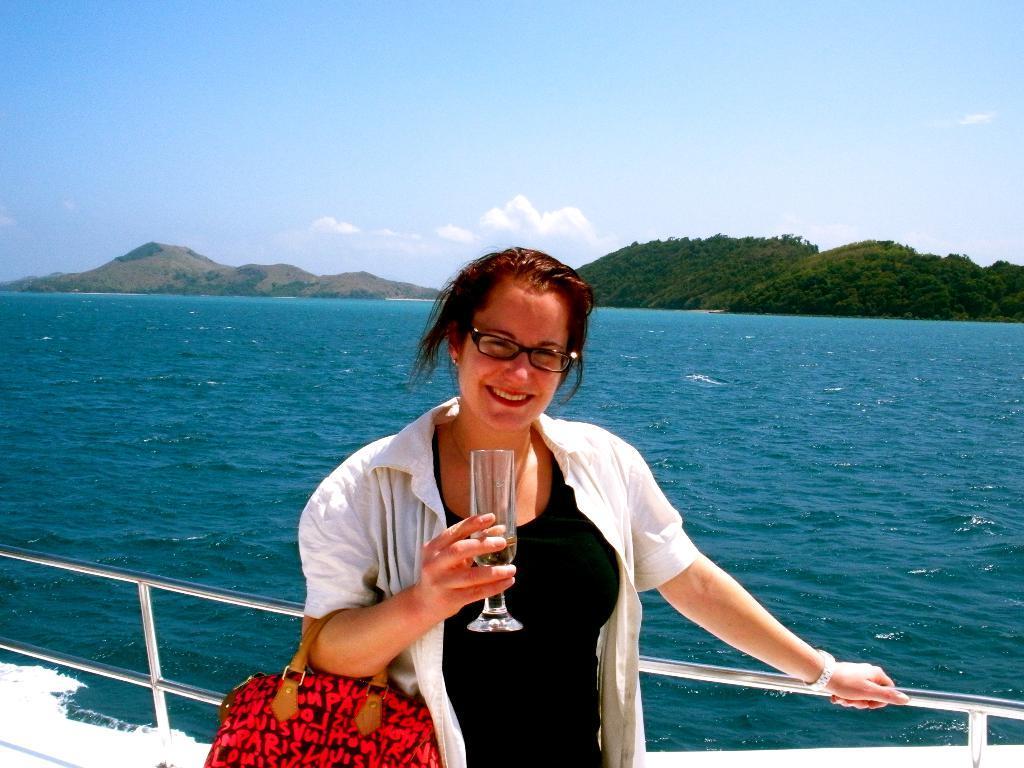How would you summarize this image in a sentence or two? In this image there is a woman who is standing in the ship by holding the hand bag and a glass in her hand. At the background there are hills and water and a sunny sky. 